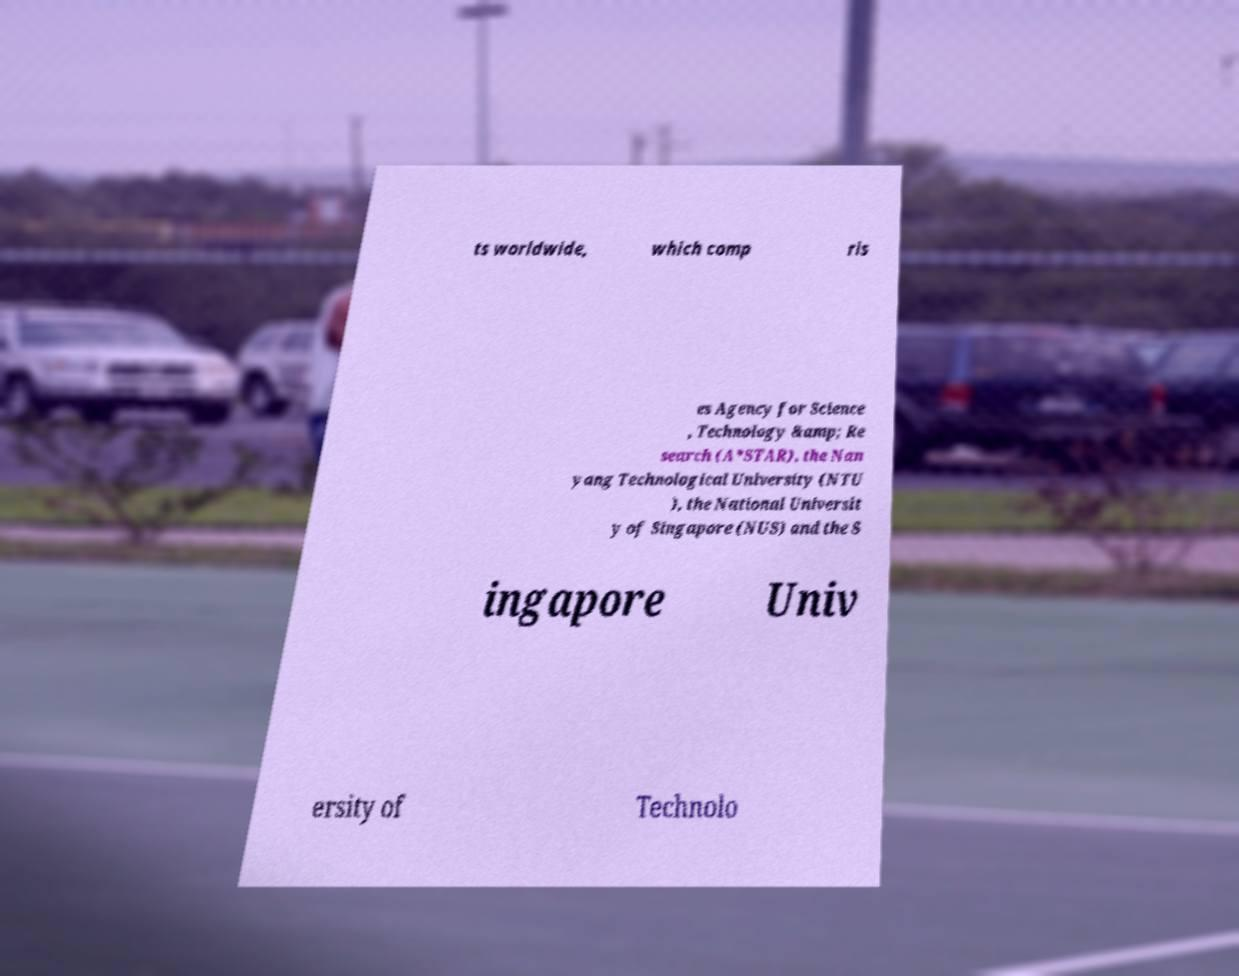Could you extract and type out the text from this image? ts worldwide, which comp ris es Agency for Science , Technology &amp; Re search (A*STAR), the Nan yang Technological University (NTU ), the National Universit y of Singapore (NUS) and the S ingapore Univ ersity of Technolo 